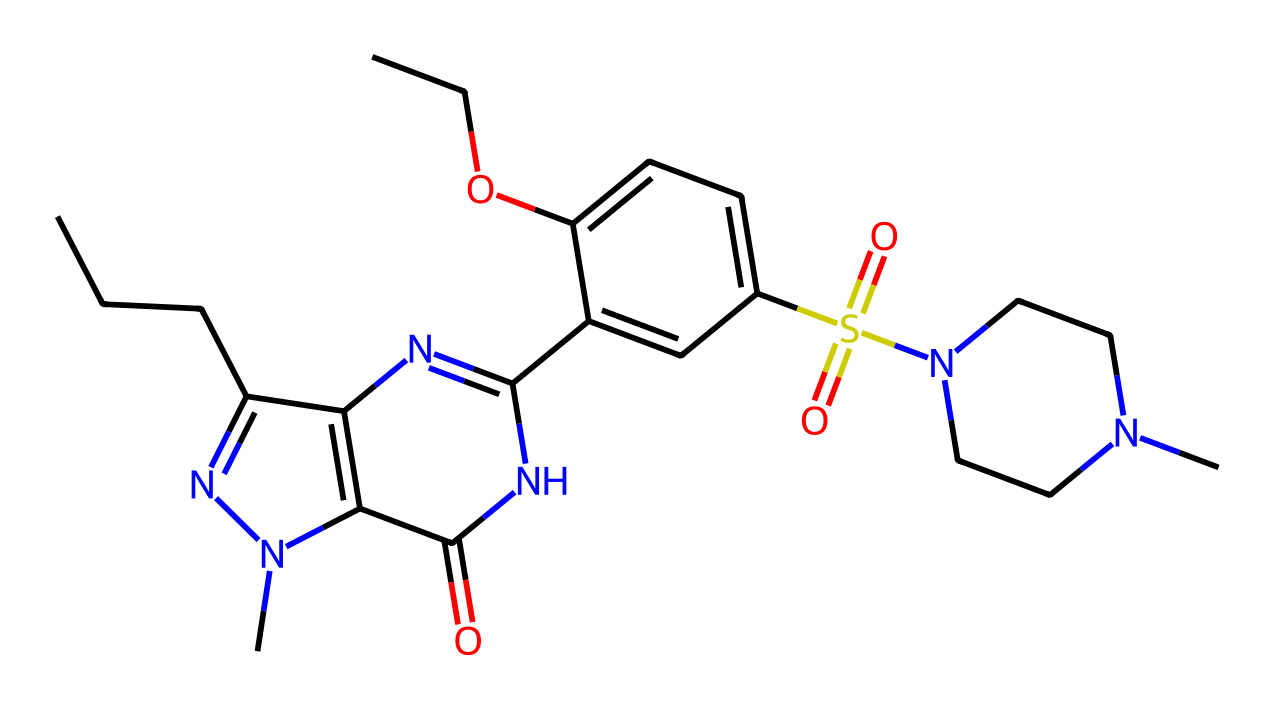What is the molecular formula of sildenafil? To determine the molecular formula from the SMILES representation, we need to count the different types of atoms present. The SMILES indicates there are carbon (C), hydrogen (H), nitrogen (N), oxygen (O), and sulfur (S) atoms. By analyzing the structure, we count 22 carbon atoms, 30 hydrogen atoms, 4 nitrogen atoms, 2 oxygen atoms, and 1 sulfur atom, yielding the molecular formula C22H30N4O2S.
Answer: C22H30N4O2S How many nitrogen atoms are present in sildenafil? The SMILES representation shows multiple nitrogen atoms, and we can identify the distinct nitrogen atoms from the structure. By visual inspection or counting them in the SMILES string, we find there are 4 nitrogen atoms.
Answer: 4 What type of functional groups are present in sildenafil? By analyzing the SMILES, we see functional groups including an amine (from the nitrogen atoms), a sulfonamide (from the sulfur and nitrogen), and a hydroxyl group (from the oxygen in the alcohol). These groups contribute to its chemical properties and biological activity.
Answer: amine, sulfonamide, hydroxyl What is the significance of the sulfonamide group in sildenafil? The sulfonamide group, characterized by the presence of sulfur and nitrogen, is crucial for the pharmacological action of sildenafil. It affects how the drug interacts with biological targets, particularly the enzyme responsible for erectile dysfunction via the inhibition of phosphodiesterase type 5 (PDE5).
Answer: pharmacological action How does the presence of multiple rings influence sildenafil’s function? The multiple ring structure in sildenafil contributes to its stability and ability to interact with specific receptors and enzymes in the body. This structural complexity is essential for its role as a PDE5 inhibitor, allowing it to fit precisely into the active sites of target proteins.
Answer: stability, receptor interaction What part of sildenafil is responsible for its selective action? The specific attachment points in sildenafil's structure, especially around the nitrogen atoms and the ring systems, provide it with selectivity for binding to the PDE5 enzyme over other enzymes. This selectivity is crucial for its effectiveness in treating erectile dysfunction without significant side effects.
Answer: attachment points 